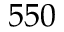<formula> <loc_0><loc_0><loc_500><loc_500>5 5 0</formula> 